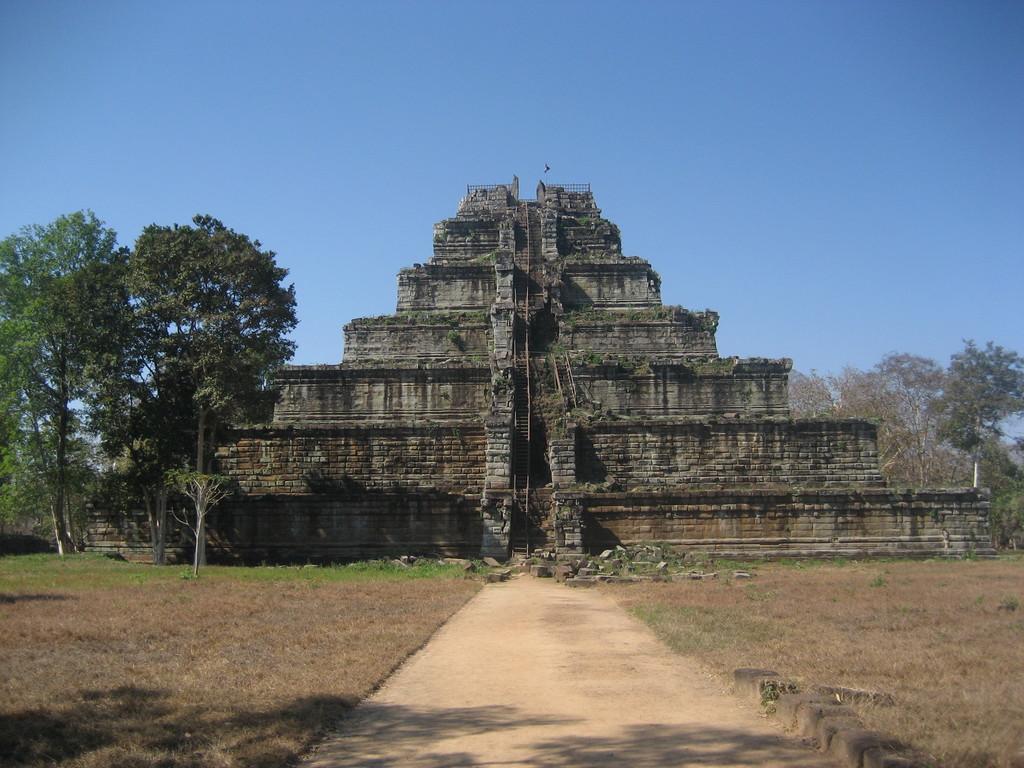Could you give a brief overview of what you see in this image? There is a Koh Ker and there are trees beside and behind it. 